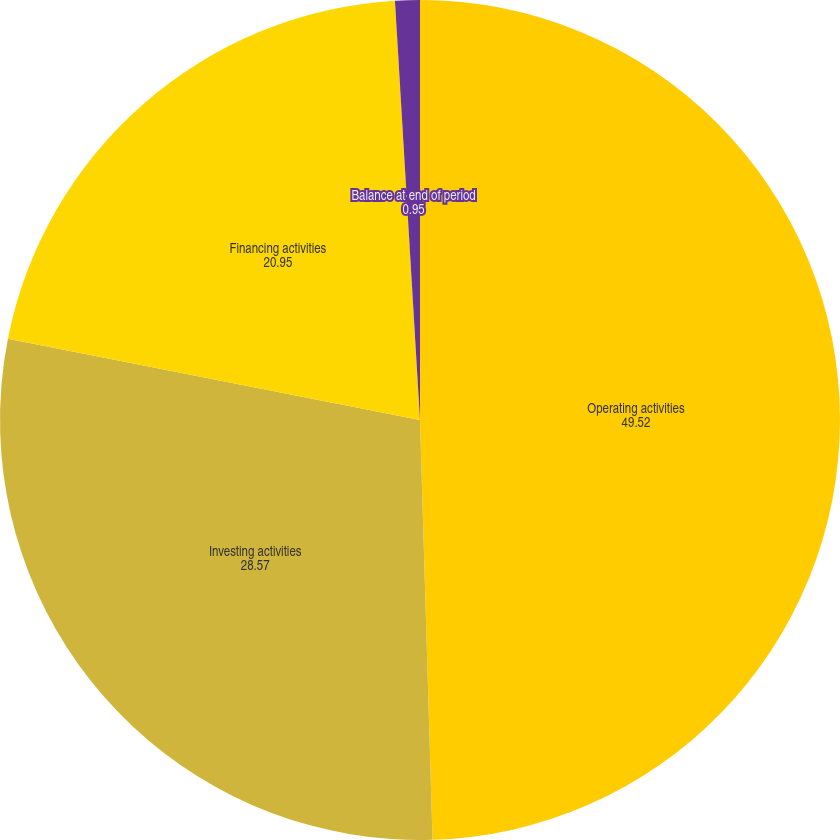Convert chart. <chart><loc_0><loc_0><loc_500><loc_500><pie_chart><fcel>Operating activities<fcel>Investing activities<fcel>Financing activities<fcel>Balance at end of period<nl><fcel>49.52%<fcel>28.57%<fcel>20.95%<fcel>0.95%<nl></chart> 